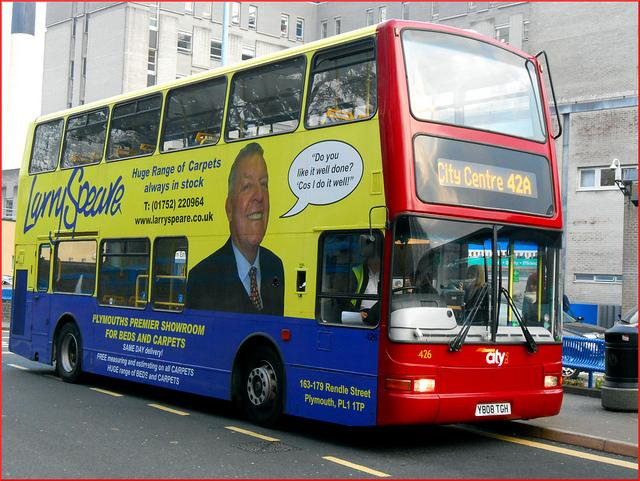What brand of bus manufacturer is displayed on the bus? Please explain your reasoning. city. As noted in white beneath the wipers. 